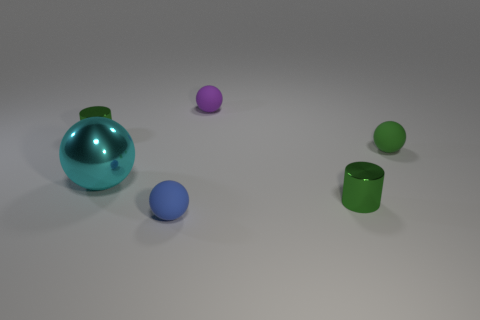How many metallic spheres have the same size as the cyan metallic object?
Your response must be concise. 0. Are there an equal number of tiny green balls right of the purple matte thing and purple spheres?
Offer a terse response. Yes. How many green cylinders are in front of the big metal object and behind the big metal sphere?
Provide a short and direct response. 0. Does the tiny green metal object that is on the right side of the blue ball have the same shape as the tiny green rubber thing?
Your answer should be compact. No. What material is the blue ball that is the same size as the purple rubber object?
Provide a short and direct response. Rubber. Is the number of purple balls that are in front of the small green matte thing the same as the number of small purple rubber balls on the left side of the large cyan metallic thing?
Ensure brevity in your answer.  Yes. How many small matte things are in front of the small green shiny object that is left of the tiny green metal object that is to the right of the metallic ball?
Your answer should be very brief. 2. Do the large shiny thing and the metallic cylinder that is behind the large cyan sphere have the same color?
Your answer should be very brief. No. What is the size of the blue sphere that is the same material as the green sphere?
Give a very brief answer. Small. Is the number of large metal things in front of the purple object greater than the number of tiny green things?
Your answer should be very brief. No. 